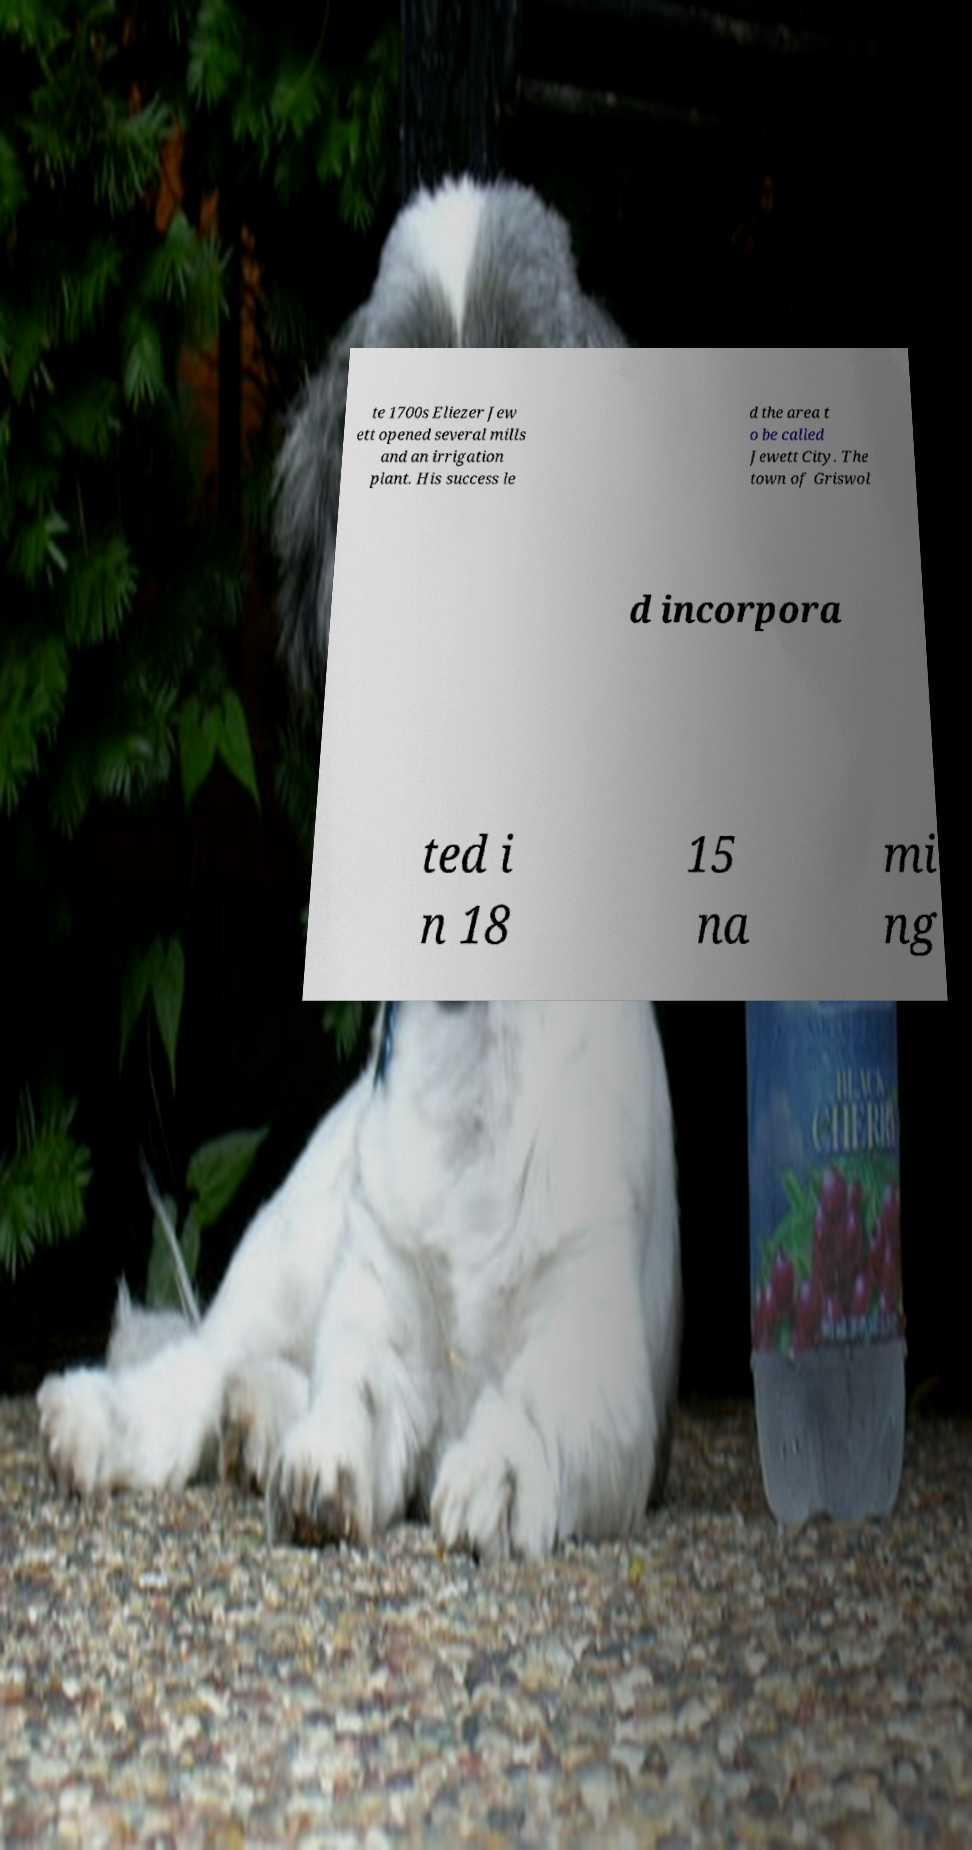Could you assist in decoding the text presented in this image and type it out clearly? te 1700s Eliezer Jew ett opened several mills and an irrigation plant. His success le d the area t o be called Jewett City. The town of Griswol d incorpora ted i n 18 15 na mi ng 